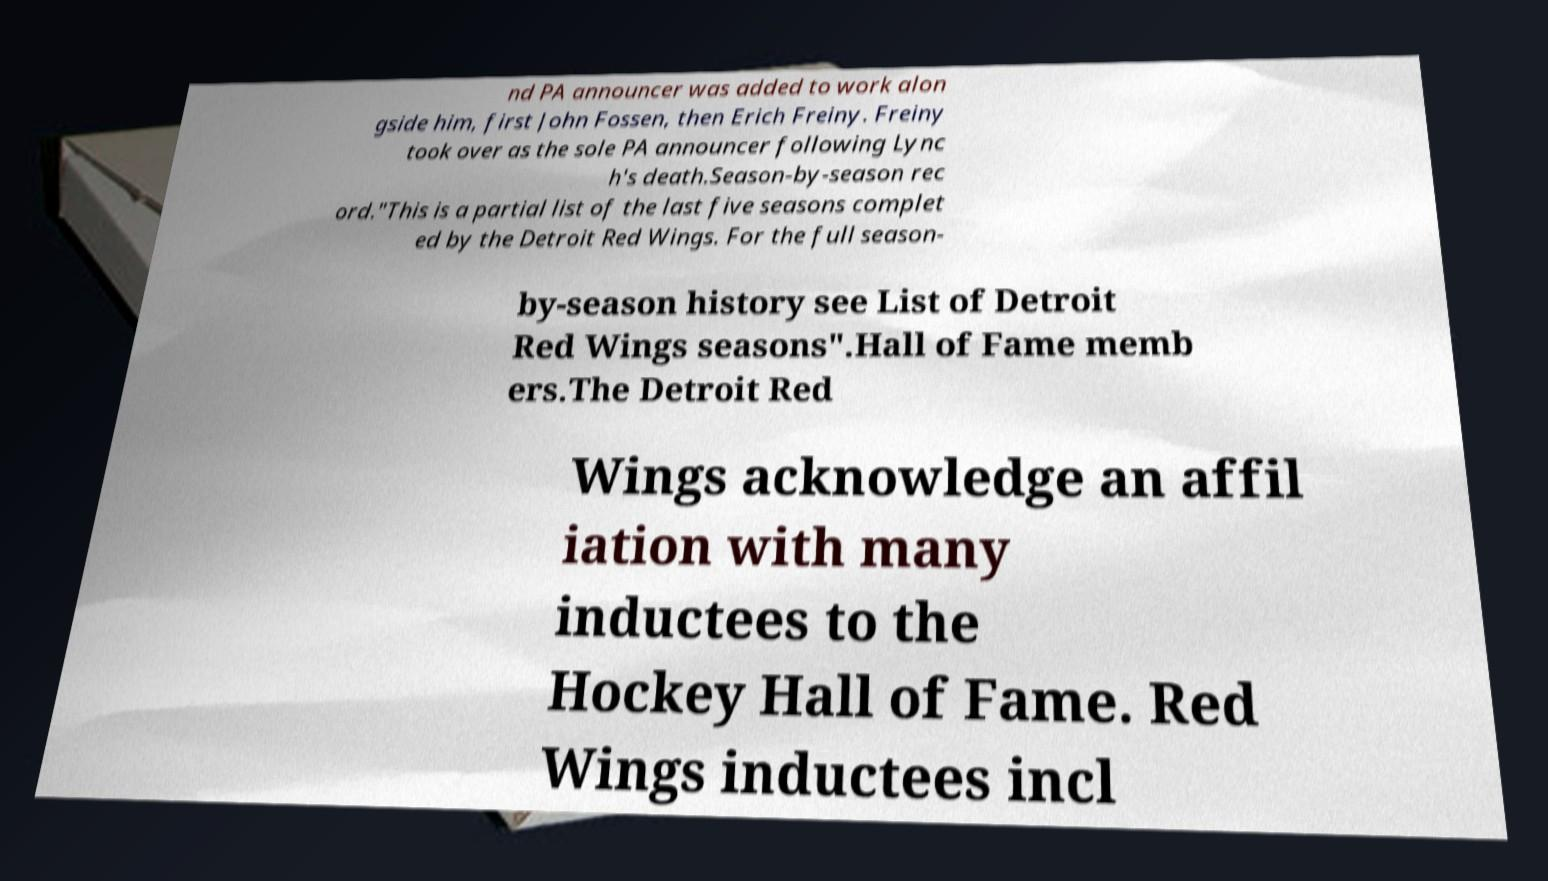There's text embedded in this image that I need extracted. Can you transcribe it verbatim? nd PA announcer was added to work alon gside him, first John Fossen, then Erich Freiny. Freiny took over as the sole PA announcer following Lync h's death.Season-by-season rec ord."This is a partial list of the last five seasons complet ed by the Detroit Red Wings. For the full season- by-season history see List of Detroit Red Wings seasons".Hall of Fame memb ers.The Detroit Red Wings acknowledge an affil iation with many inductees to the Hockey Hall of Fame. Red Wings inductees incl 